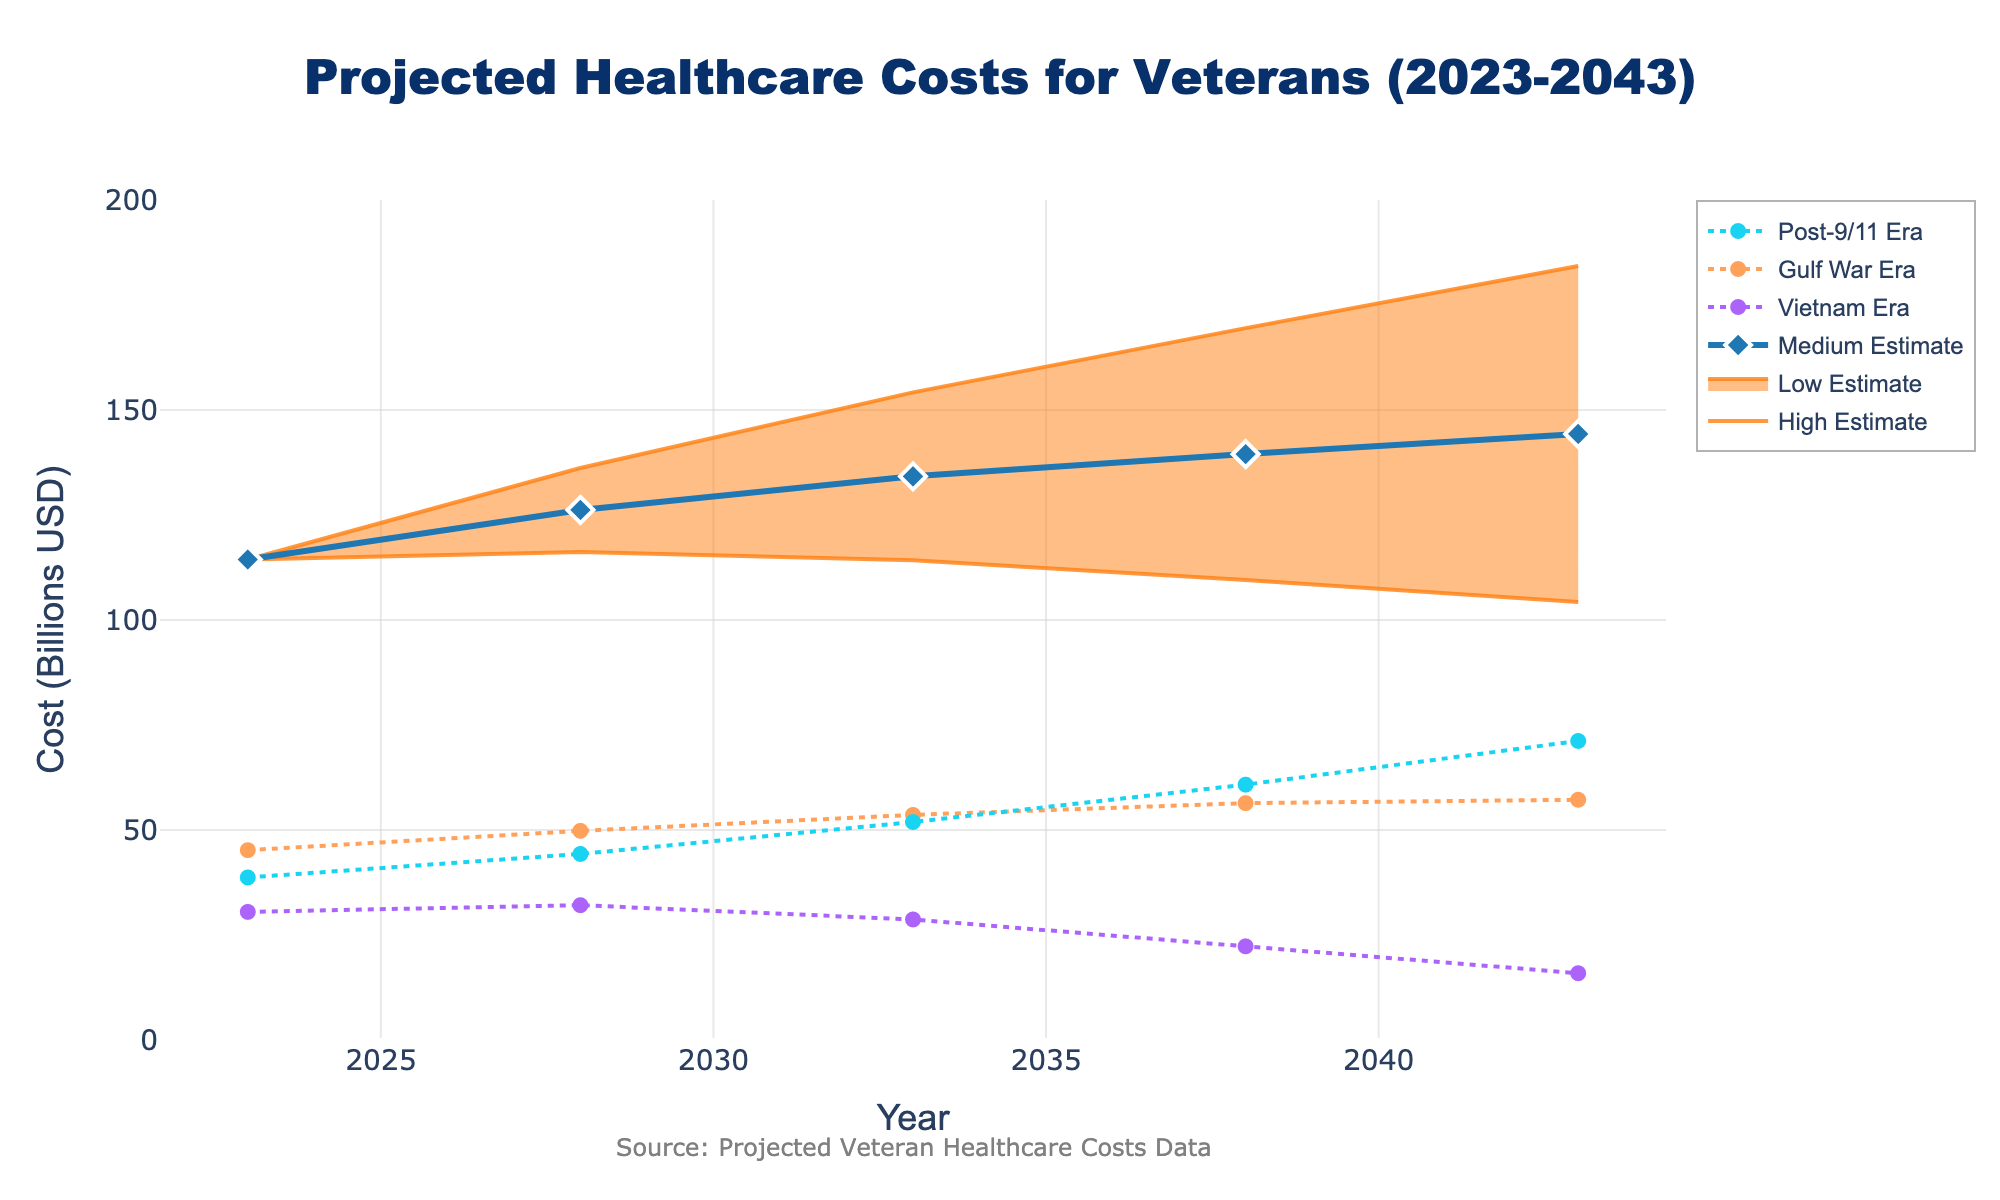What is the title of the figure? The title is "Projected Healthcare Costs for Veterans (2023-2043)", as indicated at the top of the chart.
Answer: Projected Healthcare Costs for Veterans (2023-2043) What does the y-axis represent? The y-axis represents "Cost (Billions USD)", which denotes the projected healthcare costs for veterans over the years.
Answer: Cost (Billions USD) Which era has the highest healthcare cost estimate in 2023? Looking at the endpoints in 2023, the Gulf War Era has the highest healthcare cost estimate with 45.2 billion USD.
Answer: Gulf War Era In which year does the Vietnam Era see the lowest projected healthcare cost? Observing the Vietnam Era line, the year 2043 shows the lowest projected healthcare cost at 15.9 billion USD.
Answer: 2043 What is the medium estimate for healthcare costs in 2038? The medium estimate for 2038 can be found by looking at the "Medium Estimate" line at the x-coordinate for 2038, which is 139.5 billion USD.
Answer: 139.5 By how much does the high estimate increase from 2023 to 2043? The high estimate in 2023 is 114.4 billion USD and in 2043 it is 184.3 billion USD. The difference is 184.3 - 114.4 = 69.9 billion USD.
Answer: 69.9 Compare the healthcare costs for the Vietnam Era and Post-9/11 Era in 2033. Which is higher and by how much? In 2033, Vietnam Era costs 28.7 billion USD and Post-9/11 Era costs 51.9 billion USD. The difference is 51.9 - 28.7 = 23.2 billion USD, with Post-9/11 Era being higher.
Answer: Post-9/11 Era by 23.2 billion USD What is the trend in the total projected healthcare costs from 2023 to 2043 based on the medium estimate? The medium estimate shows an increasing trend in total projected healthcare costs from 2023 (114.4 billion USD) to 2043 (144.3 billion USD).
Answer: Increasing What qualitative difference can you observe between the service era lines and the estimate lines? The service era lines (Vietnam, Gulf War, Post-9/11) show an up-and-down pattern with dots, while the estimate lines (Low, Medium, High) provide a band representation with a shaded area between Low and High.
Answer: Service era lines vary, estimate lines band 